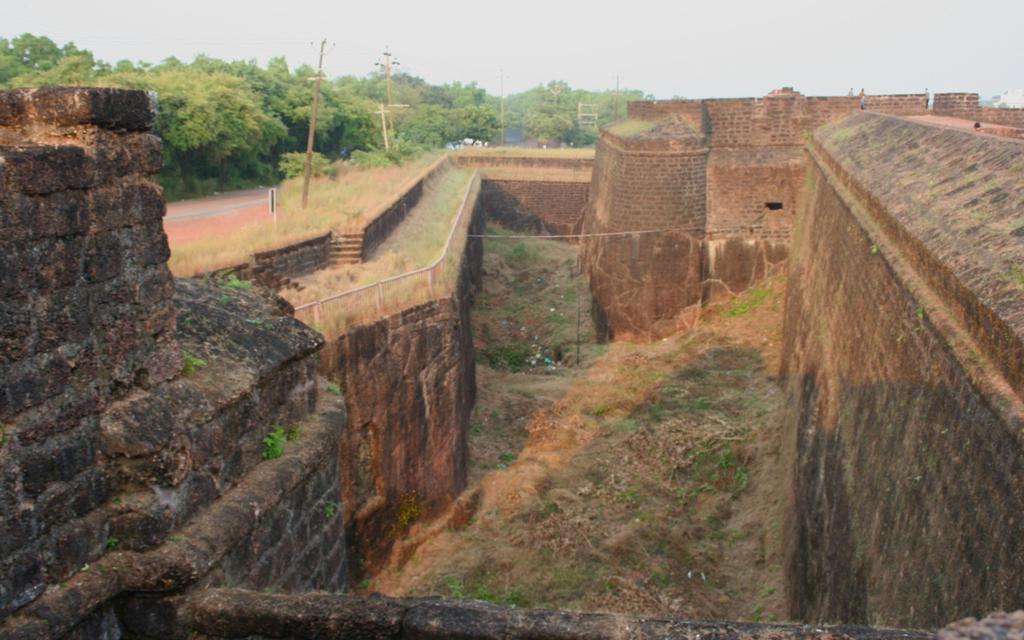Could you give a brief overview of what you see in this image? In the picture I can see a fort, wall, the grass, poles, trees and a road. In the background I can see the sky. 